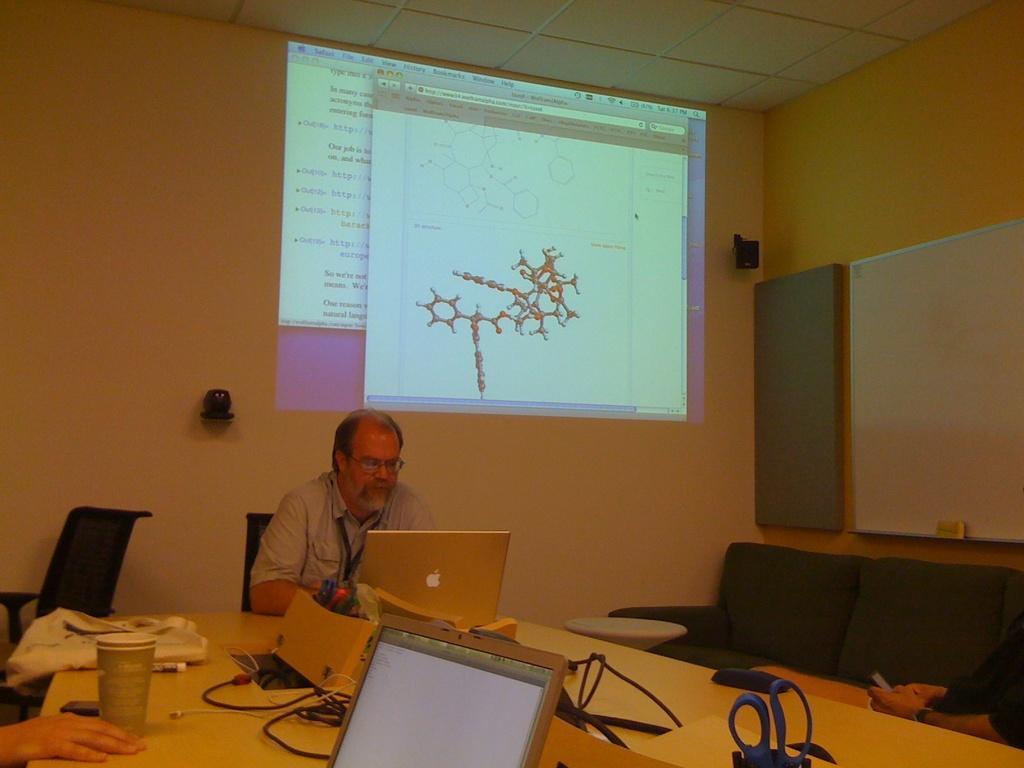Could you give a brief overview of what you see in this image? On the background we can see a screen, speaker , whiteboard with duster. We can see few empty chairs and a table. We can see one man , he wore spectacles., Sitting on a chair in front of a table and on the table we can see scissors, laptops, glass. 